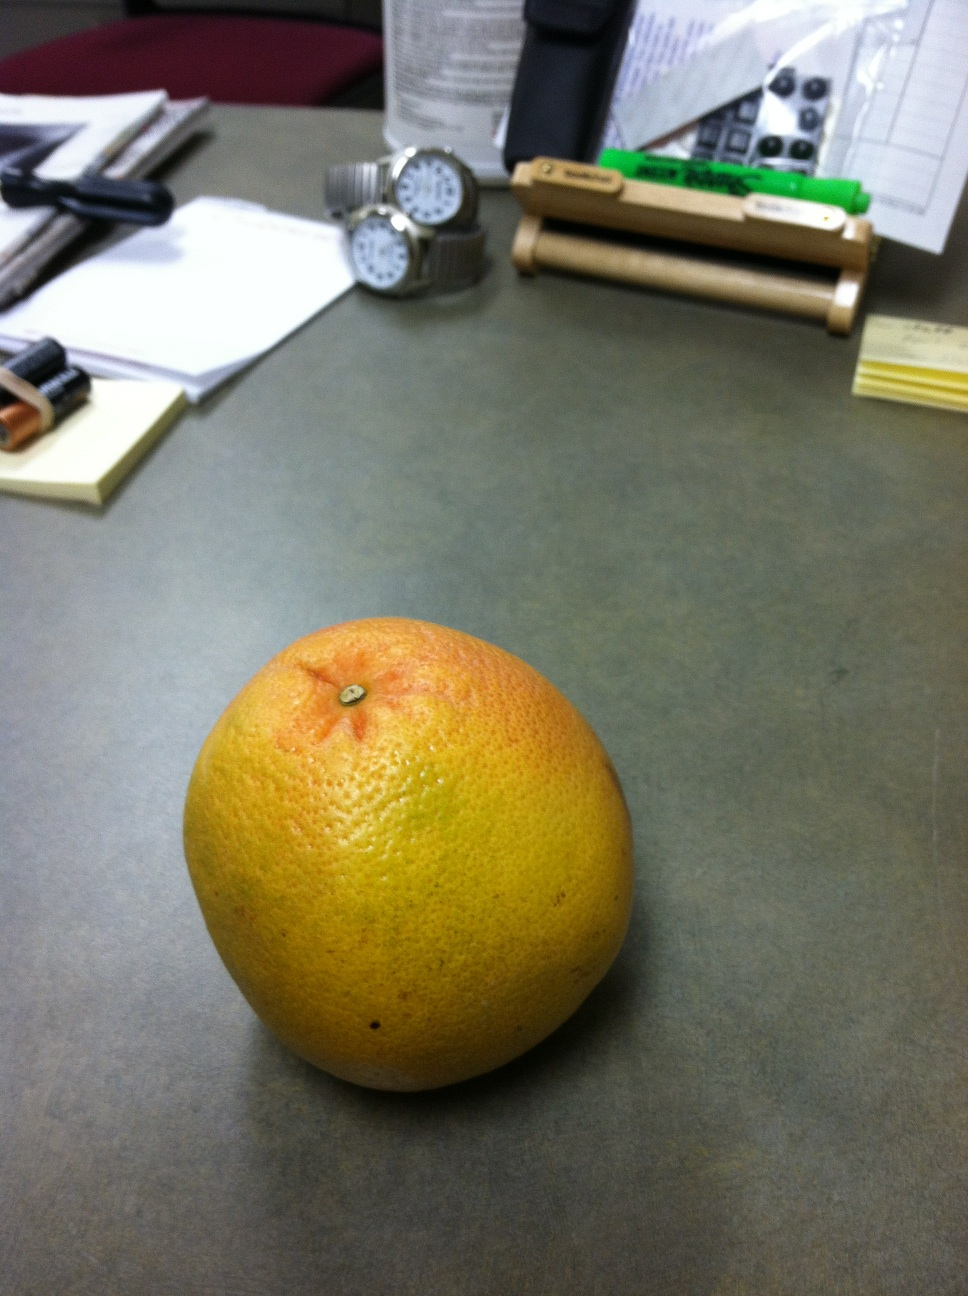What kind of uses does this fruit have in the kitchen? This fruit is quite versatile. It can be eaten fresh, added to fruit salads, or used to make a refreshing grapefruit sorbet. Its zest and juice can also be used to add a zing to marinades or cocktails, and it's an excellent complement to seafood. Could you tell me how to prepare it for eating? Certainly! To prepare it, slice the fruit in half horizontally to expose the segments. You can then use a knife to separate the flesh from the membrane, or if you like, you can eat it with a spoon directly from the rind, scooping out bite-sized pieces. 